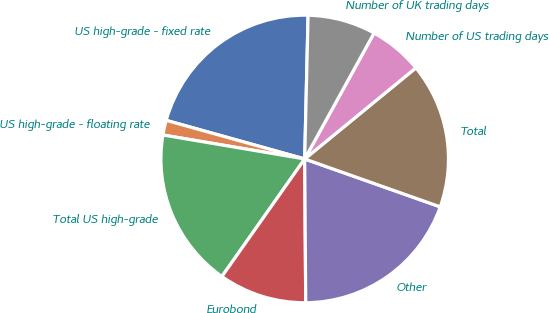Convert chart to OTSL. <chart><loc_0><loc_0><loc_500><loc_500><pie_chart><fcel>US high-grade - fixed rate<fcel>US high-grade - floating rate<fcel>Total US high-grade<fcel>Eurobond<fcel>Other<fcel>Total<fcel>Number of US trading days<fcel>Number of UK trading days<nl><fcel>21.05%<fcel>1.66%<fcel>17.9%<fcel>9.88%<fcel>19.48%<fcel>16.33%<fcel>6.06%<fcel>7.64%<nl></chart> 